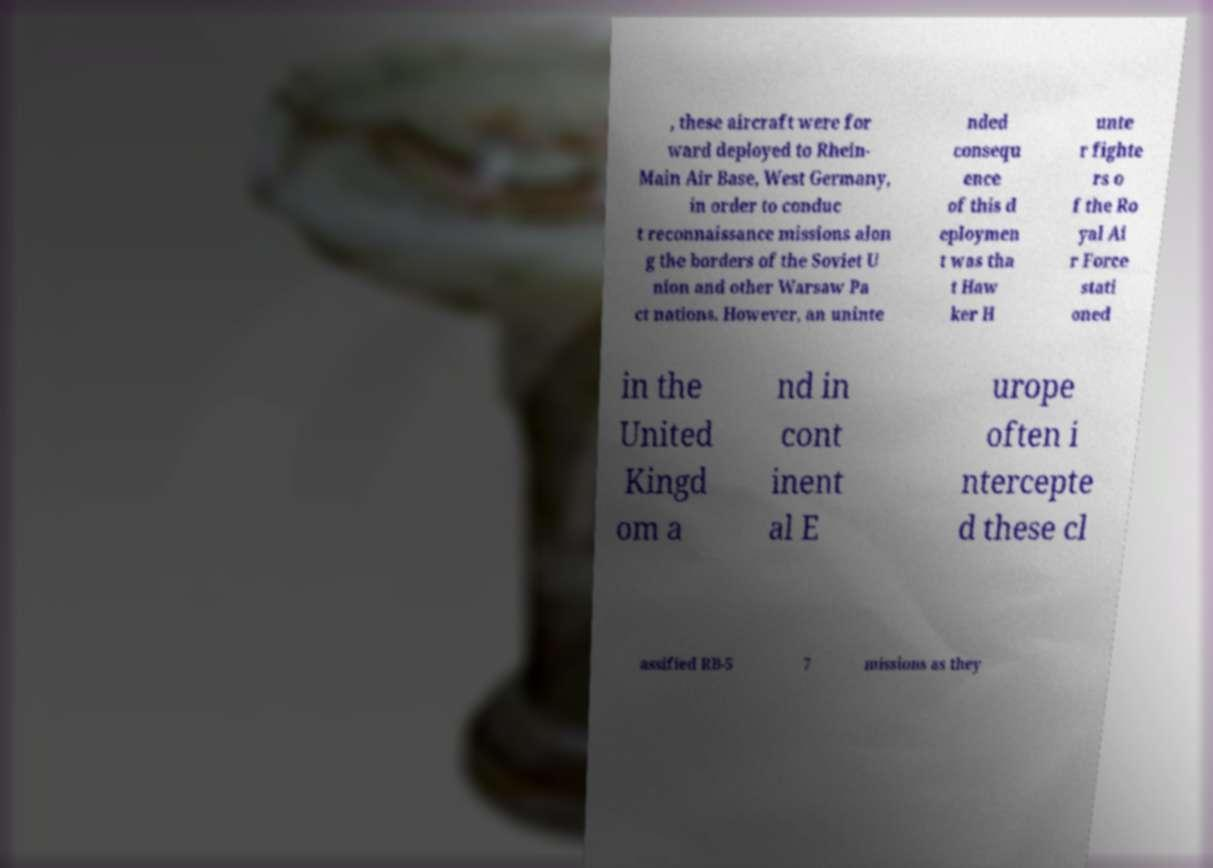What messages or text are displayed in this image? I need them in a readable, typed format. , these aircraft were for ward deployed to Rhein- Main Air Base, West Germany, in order to conduc t reconnaissance missions alon g the borders of the Soviet U nion and other Warsaw Pa ct nations. However, an uninte nded consequ ence of this d eploymen t was tha t Haw ker H unte r fighte rs o f the Ro yal Ai r Force stati oned in the United Kingd om a nd in cont inent al E urope often i ntercepte d these cl assified RB-5 7 missions as they 